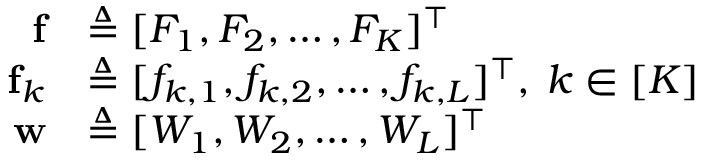<formula> <loc_0><loc_0><loc_500><loc_500>\begin{array} { r l } { f } & { \triangle q [ F _ { 1 } , F _ { 2 } , \hdots , F _ { K } ] ^ { \intercal } } \\ { f _ { k } } & { \triangle q [ f _ { k , 1 } , f _ { k , 2 } , \hdots , f _ { k , L } ] ^ { \intercal } , \, k \in [ K ] } \\ { w } & { \triangle q [ W _ { 1 } , W _ { 2 } , \hdots , W _ { L } ] ^ { \intercal } } \end{array}</formula> 